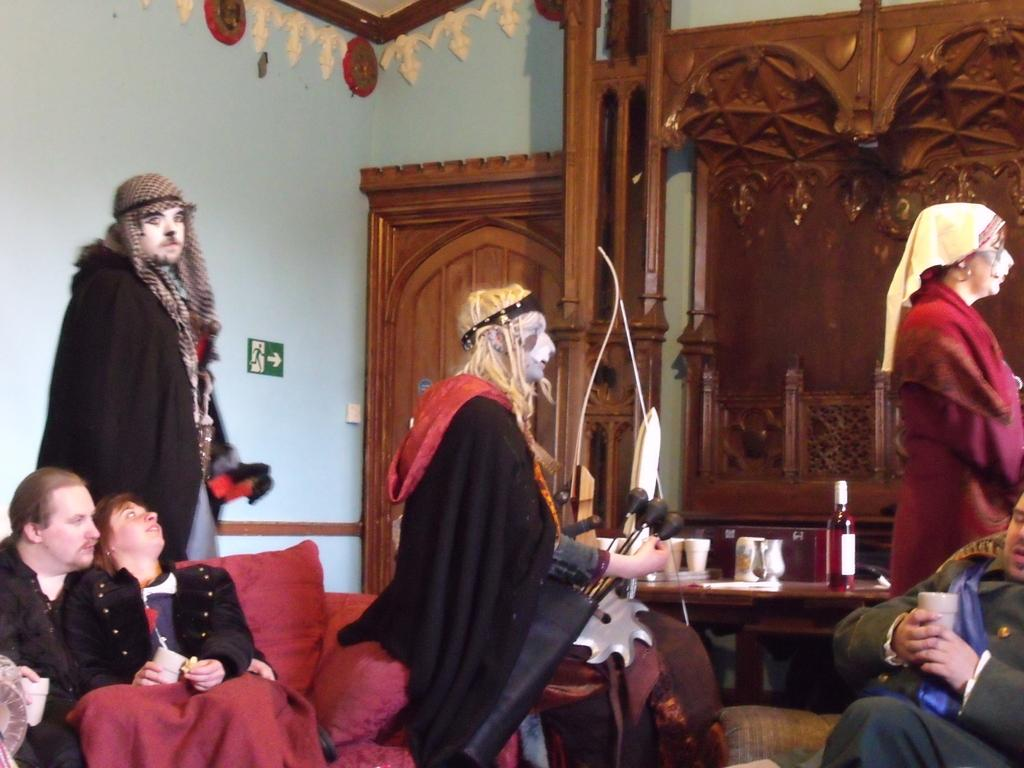What is a notable characteristic of the people in the image? The people in the image have painted faces. What are the people in the image doing? The people are sitting in the image. Can you describe a feature of the setting in the image? There is a door in the image. What object can be seen in the image that might contain a liquid? There is a bottle in the image. What type of structure is visible in the image? There is a wall in the image. What material is used for some of the objects in the image? There are wooden objects in the image. What time of day is it in the image, considering the presence of night? There is no mention of night or any indication of the time of day in the image. 